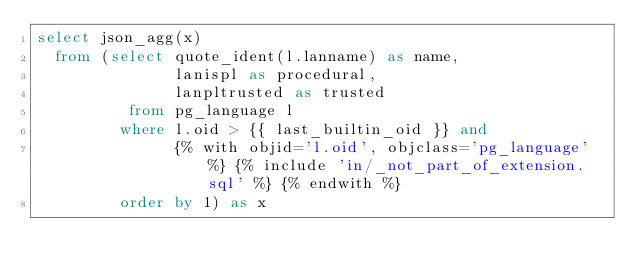Convert code to text. <code><loc_0><loc_0><loc_500><loc_500><_SQL_>select json_agg(x)
  from (select quote_ident(l.lanname) as name,
               lanispl as procedural,
               lanpltrusted as trusted
          from pg_language l
         where l.oid > {{ last_builtin_oid }} and
               {% with objid='l.oid', objclass='pg_language' %} {% include 'in/_not_part_of_extension.sql' %} {% endwith %}
         order by 1) as x
</code> 